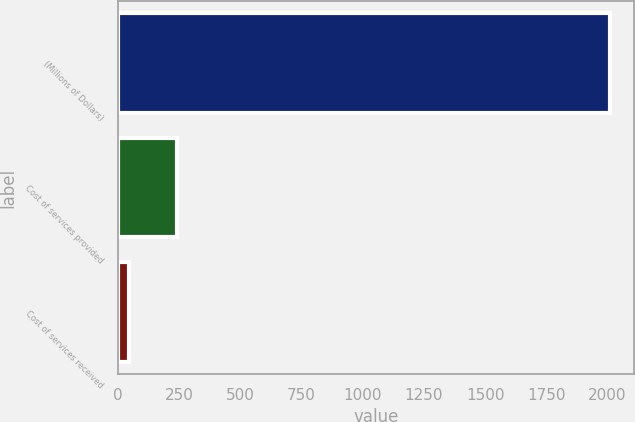Convert chart to OTSL. <chart><loc_0><loc_0><loc_500><loc_500><bar_chart><fcel>(Millions of Dollars)<fcel>Cost of services provided<fcel>Cost of services received<nl><fcel>2010<fcel>241.5<fcel>45<nl></chart> 